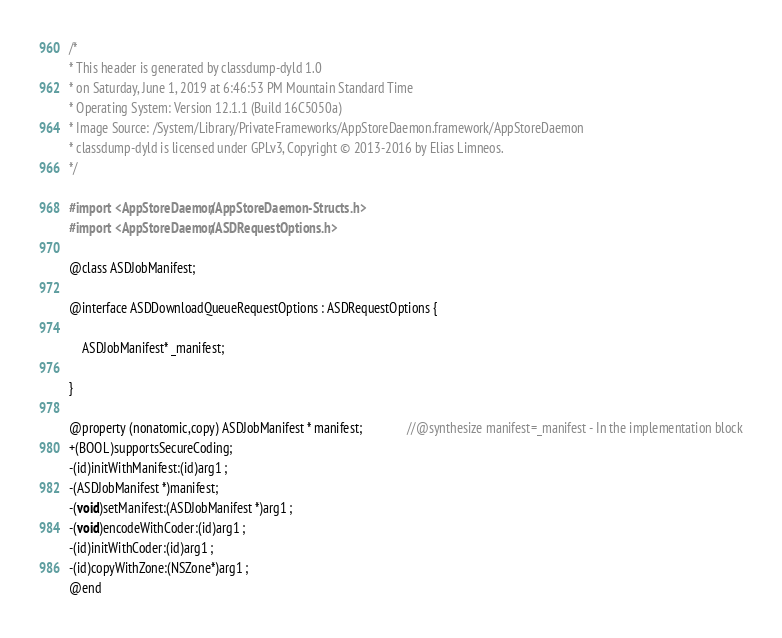Convert code to text. <code><loc_0><loc_0><loc_500><loc_500><_C_>/*
* This header is generated by classdump-dyld 1.0
* on Saturday, June 1, 2019 at 6:46:53 PM Mountain Standard Time
* Operating System: Version 12.1.1 (Build 16C5050a)
* Image Source: /System/Library/PrivateFrameworks/AppStoreDaemon.framework/AppStoreDaemon
* classdump-dyld is licensed under GPLv3, Copyright © 2013-2016 by Elias Limneos.
*/

#import <AppStoreDaemon/AppStoreDaemon-Structs.h>
#import <AppStoreDaemon/ASDRequestOptions.h>

@class ASDJobManifest;

@interface ASDDownloadQueueRequestOptions : ASDRequestOptions {

	ASDJobManifest* _manifest;

}

@property (nonatomic,copy) ASDJobManifest * manifest;              //@synthesize manifest=_manifest - In the implementation block
+(BOOL)supportsSecureCoding;
-(id)initWithManifest:(id)arg1 ;
-(ASDJobManifest *)manifest;
-(void)setManifest:(ASDJobManifest *)arg1 ;
-(void)encodeWithCoder:(id)arg1 ;
-(id)initWithCoder:(id)arg1 ;
-(id)copyWithZone:(NSZone*)arg1 ;
@end

</code> 